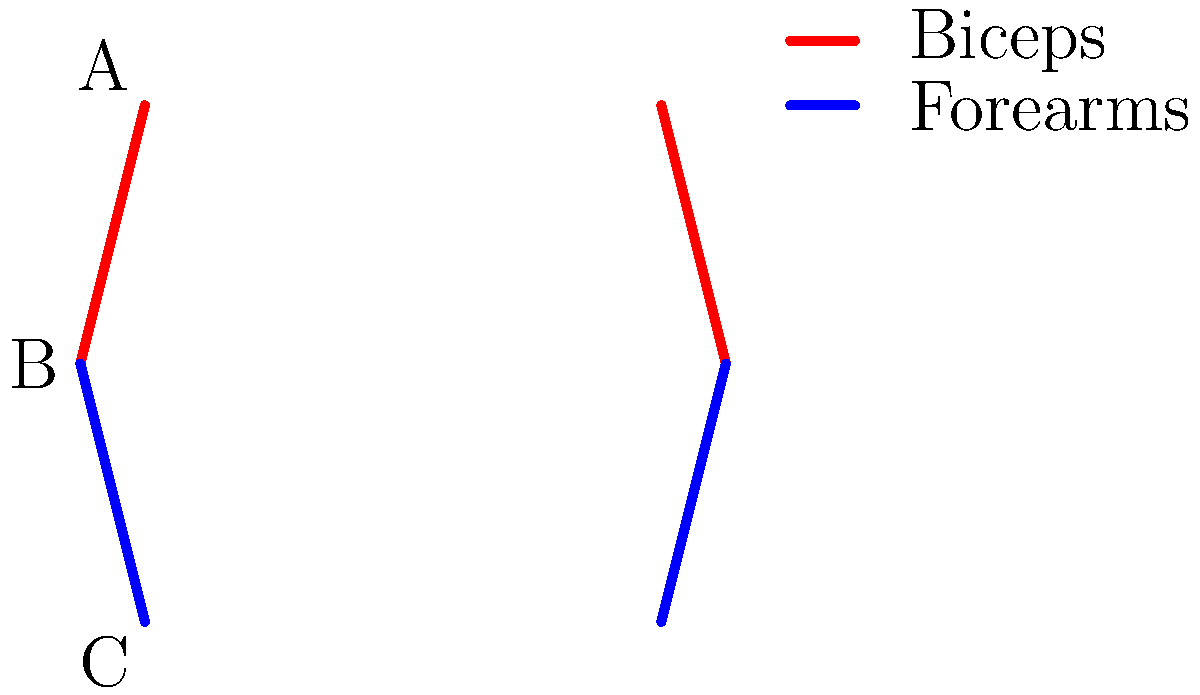In the context of street art techniques like graffiti, which muscle group (A, B, or C) is likely to experience the highest activation during the creation of large-scale murals, and why would this information be valuable for marketing athletic wear to urban artists? To answer this question, let's break down the biomechanics of creating large-scale murals in street art:

1. Muscle group A represents the shoulders and upper arms (deltoids and biceps).
2. Muscle group B represents the elbows and forearms.
3. Muscle group C represents the wrists and hands.

Step 1: Analyze the movements involved in creating large-scale murals:
- Reaching and extending arms to cover large areas
- Repetitive motions for consistent line work and shading
- Holding spray cans or other tools for extended periods

Step 2: Consider the primary functions of each muscle group:
- A (shoulders/biceps): Lifting and extending arms
- B (forearms): Gripping and controlling tools
- C (wrists/hands): Fine motor control and precision movements

Step 3: Determine the most stressed muscle group:
Group B (forearms) is likely to experience the highest activation because:
- It's responsible for gripping and controlling spray cans or brushes
- It's involved in repetitive motions for extended periods
- It stabilizes the wrist for precise movements

Step 4: Marketing value of this information:
- Develop specialized athletic wear that provides support and comfort for the forearms
- Create marketing campaigns highlighting the importance of forearm strength and endurance in street art
- Design products that alleviate strain on the forearms during long painting sessions

This biomechanical insight allows marketers to:
1. Target their products specifically to urban artists' needs
2. Position their brand as understanding and supporting the street art community
3. Differentiate their products from general athletic wear
Answer: B (forearms); enables targeted product development and marketing for urban artists 